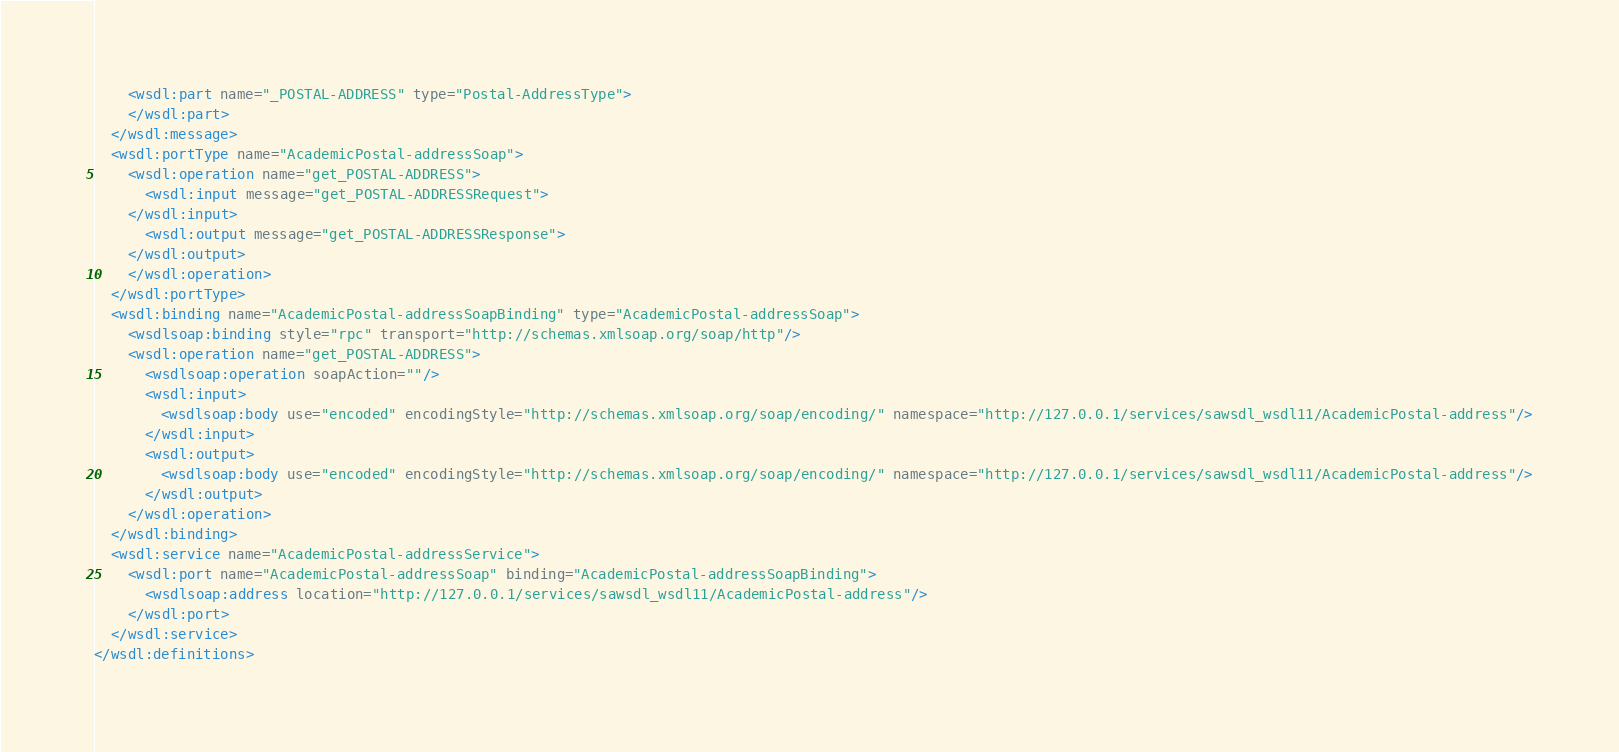Convert code to text. <code><loc_0><loc_0><loc_500><loc_500><_XML_>    <wsdl:part name="_POSTAL-ADDRESS" type="Postal-AddressType">
    </wsdl:part>
  </wsdl:message>
  <wsdl:portType name="AcademicPostal-addressSoap">
    <wsdl:operation name="get_POSTAL-ADDRESS">
      <wsdl:input message="get_POSTAL-ADDRESSRequest">
    </wsdl:input>
      <wsdl:output message="get_POSTAL-ADDRESSResponse">
    </wsdl:output>
    </wsdl:operation>
  </wsdl:portType>
  <wsdl:binding name="AcademicPostal-addressSoapBinding" type="AcademicPostal-addressSoap">
    <wsdlsoap:binding style="rpc" transport="http://schemas.xmlsoap.org/soap/http"/>
    <wsdl:operation name="get_POSTAL-ADDRESS">
      <wsdlsoap:operation soapAction=""/>
      <wsdl:input>
        <wsdlsoap:body use="encoded" encodingStyle="http://schemas.xmlsoap.org/soap/encoding/" namespace="http://127.0.0.1/services/sawsdl_wsdl11/AcademicPostal-address"/>
      </wsdl:input>
      <wsdl:output>
        <wsdlsoap:body use="encoded" encodingStyle="http://schemas.xmlsoap.org/soap/encoding/" namespace="http://127.0.0.1/services/sawsdl_wsdl11/AcademicPostal-address"/>
      </wsdl:output>
    </wsdl:operation>
  </wsdl:binding>
  <wsdl:service name="AcademicPostal-addressService">
    <wsdl:port name="AcademicPostal-addressSoap" binding="AcademicPostal-addressSoapBinding">
      <wsdlsoap:address location="http://127.0.0.1/services/sawsdl_wsdl11/AcademicPostal-address"/>
    </wsdl:port>
  </wsdl:service>
</wsdl:definitions>
</code> 